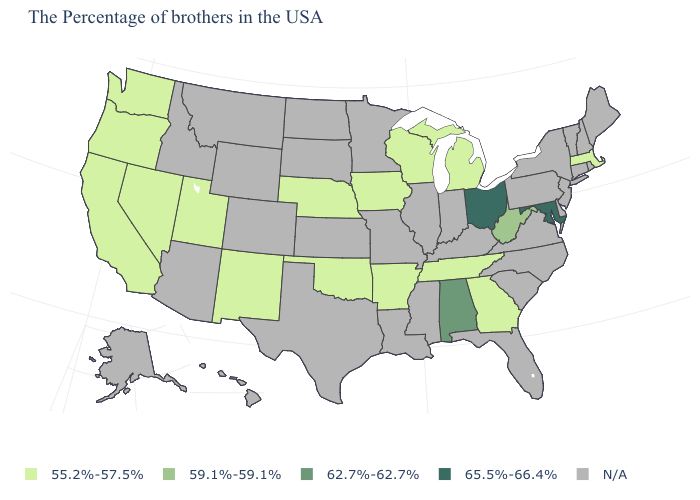Among the states that border Idaho , which have the lowest value?
Write a very short answer. Utah, Nevada, Washington, Oregon. What is the value of Indiana?
Keep it brief. N/A. Which states hav the highest value in the MidWest?
Write a very short answer. Ohio. What is the value of North Carolina?
Be succinct. N/A. Which states hav the highest value in the West?
Keep it brief. New Mexico, Utah, Nevada, California, Washington, Oregon. What is the value of Nevada?
Give a very brief answer. 55.2%-57.5%. Among the states that border Colorado , which have the lowest value?
Quick response, please. Nebraska, Oklahoma, New Mexico, Utah. Name the states that have a value in the range 55.2%-57.5%?
Give a very brief answer. Massachusetts, Georgia, Michigan, Tennessee, Wisconsin, Arkansas, Iowa, Nebraska, Oklahoma, New Mexico, Utah, Nevada, California, Washington, Oregon. What is the value of Montana?
Short answer required. N/A. Which states hav the highest value in the West?
Concise answer only. New Mexico, Utah, Nevada, California, Washington, Oregon. Among the states that border Minnesota , which have the lowest value?
Short answer required. Wisconsin, Iowa. Does the first symbol in the legend represent the smallest category?
Concise answer only. Yes. What is the value of Connecticut?
Be succinct. N/A. 